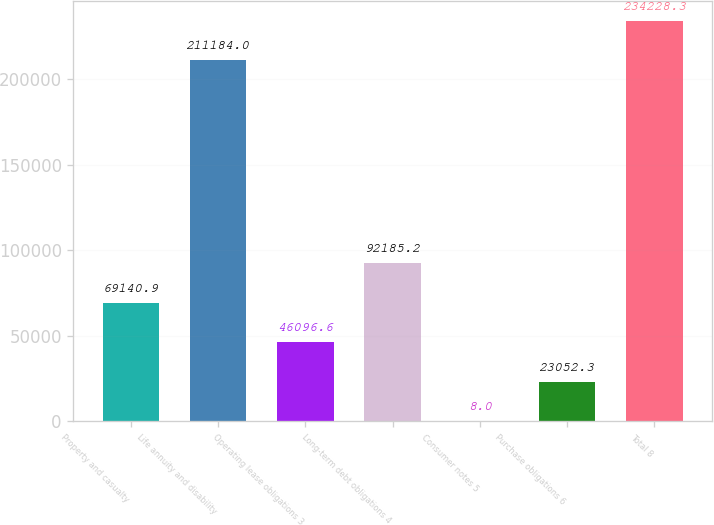Convert chart. <chart><loc_0><loc_0><loc_500><loc_500><bar_chart><fcel>Property and casualty<fcel>Life annuity and disability<fcel>Operating lease obligations 3<fcel>Long-term debt obligations 4<fcel>Consumer notes 5<fcel>Purchase obligations 6<fcel>Total 8<nl><fcel>69140.9<fcel>211184<fcel>46096.6<fcel>92185.2<fcel>8<fcel>23052.3<fcel>234228<nl></chart> 